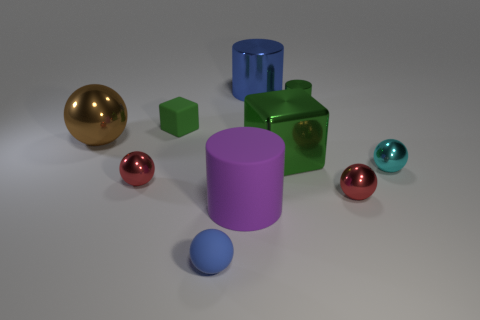Subtract all cubes. How many objects are left? 8 Subtract 0 purple balls. How many objects are left? 10 Subtract all yellow matte spheres. Subtract all purple things. How many objects are left? 9 Add 4 tiny rubber blocks. How many tiny rubber blocks are left? 5 Add 2 blue things. How many blue things exist? 4 